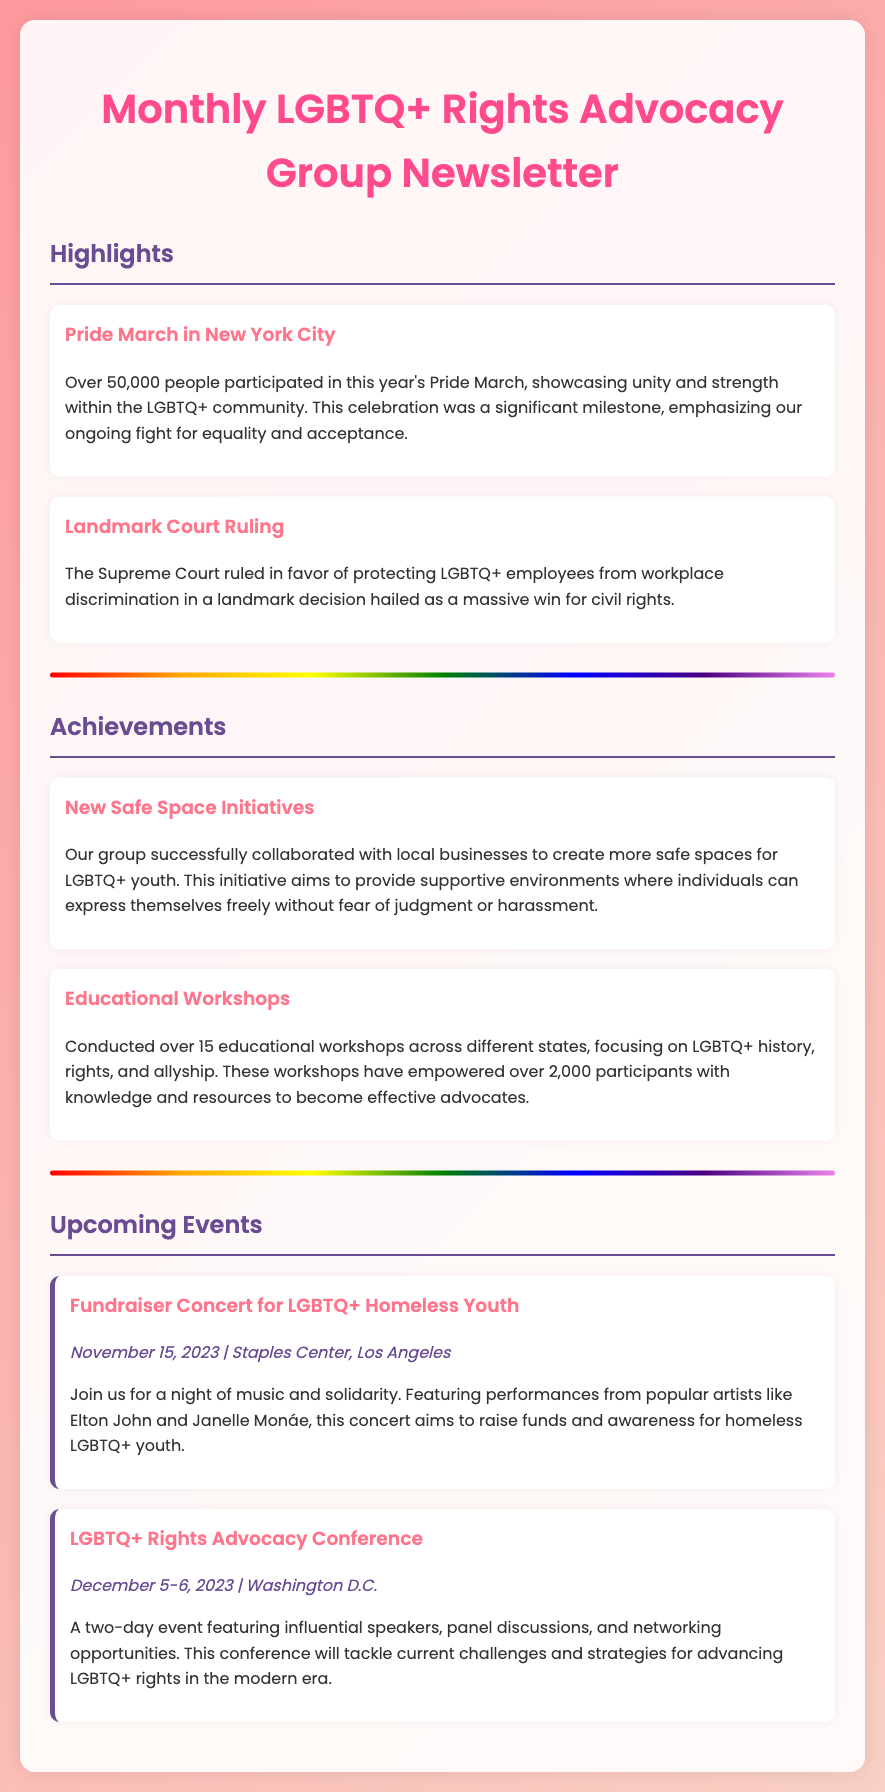What event had over 50,000 participants? The document highlights the Pride March in New York City as an event with over 50,000 participants.
Answer: Pride March in New York City What is the date of the Fundraiser Concert for LGBTQ+ Homeless Youth? The document specifies the date of the Fundraiser Concert as November 15, 2023.
Answer: November 15, 2023 How many educational workshops were conducted? According to the document, over 15 educational workshops were conducted across different states.
Answer: over 15 Who are the featured artists at the Fundraiser Concert? The document names Elton John and Janelle Monáe as the featured artists for the Fundraiser Concert.
Answer: Elton John and Janelle Monáe What city will host the LGBTQ+ Rights Advocacy Conference? The document indicates that the LGBTQ+ Rights Advocacy Conference will be held in Washington D.C.
Answer: Washington D.C How many participants were empowered by the educational workshops? The document states that over 2,000 participants were empowered through the workshops.
Answer: over 2,000 